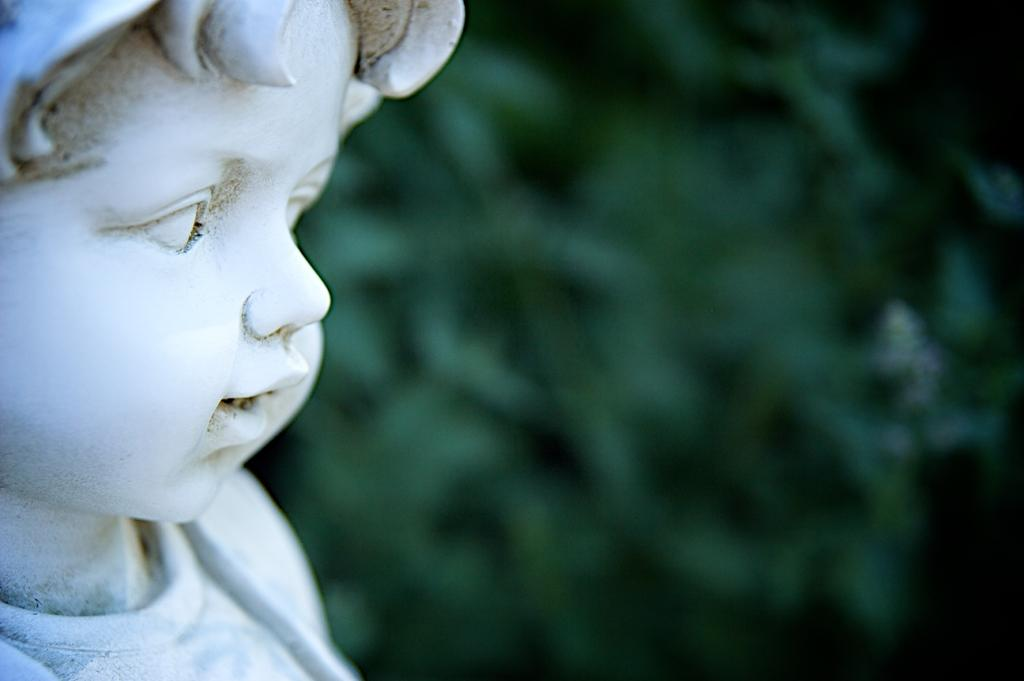What is located on the left side of the image? There is a statue of a baby on the left side of the image. What color is the background of the image? The background of the image is green in color. How is the background of the image depicted? The background of the image is blurred. What type of tomatoes are being discussed in the class in the image? There is no class or discussion of tomatoes present in the image. What fictional character is depicted in the image? There is no fictional character depicted in the image; it features a statue of a baby. 